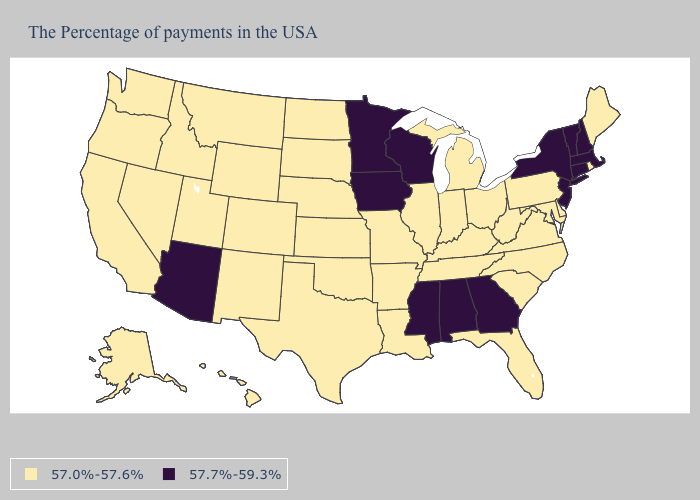Name the states that have a value in the range 57.7%-59.3%?
Quick response, please. Massachusetts, New Hampshire, Vermont, Connecticut, New York, New Jersey, Georgia, Alabama, Wisconsin, Mississippi, Minnesota, Iowa, Arizona. Name the states that have a value in the range 57.7%-59.3%?
Write a very short answer. Massachusetts, New Hampshire, Vermont, Connecticut, New York, New Jersey, Georgia, Alabama, Wisconsin, Mississippi, Minnesota, Iowa, Arizona. What is the value of Alabama?
Keep it brief. 57.7%-59.3%. What is the value of Virginia?
Give a very brief answer. 57.0%-57.6%. What is the value of Iowa?
Concise answer only. 57.7%-59.3%. Which states hav the highest value in the West?
Quick response, please. Arizona. Does the map have missing data?
Write a very short answer. No. How many symbols are there in the legend?
Give a very brief answer. 2. Which states have the highest value in the USA?
Answer briefly. Massachusetts, New Hampshire, Vermont, Connecticut, New York, New Jersey, Georgia, Alabama, Wisconsin, Mississippi, Minnesota, Iowa, Arizona. What is the value of Alabama?
Write a very short answer. 57.7%-59.3%. What is the highest value in the USA?
Write a very short answer. 57.7%-59.3%. What is the highest value in the USA?
Be succinct. 57.7%-59.3%. Name the states that have a value in the range 57.7%-59.3%?
Be succinct. Massachusetts, New Hampshire, Vermont, Connecticut, New York, New Jersey, Georgia, Alabama, Wisconsin, Mississippi, Minnesota, Iowa, Arizona. What is the value of Florida?
Answer briefly. 57.0%-57.6%. What is the value of California?
Keep it brief. 57.0%-57.6%. 